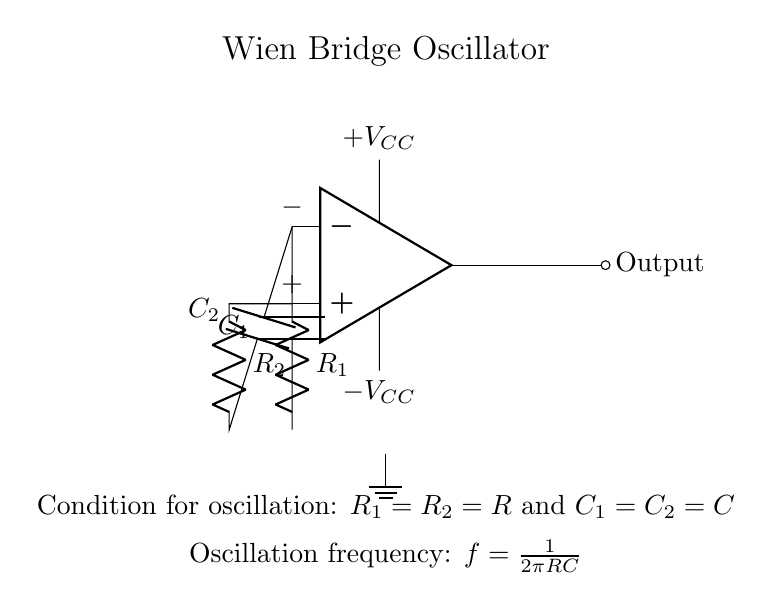What type of amplifier is used in the circuit? The circuit utilizes an operational amplifier (op-amp) as indicated by the symbol in the diagram.
Answer: operational amplifier What components are used to determine the oscillation frequency? The oscillation frequency depends on the resistors R and capacitors C, as described by the formula in the diagram.
Answer: R and C What is the condition for oscillation in this circuit? The condition for oscillation requires that both resistors R1 and R2 be equal, and that both capacitors C1 and C2 be equal, as specified in the circuit.
Answer: R1 = R2 and C1 = C2 What is the output connection type? The output is connected through a short to a node indicated as output (node on the right).
Answer: short What is the formula for oscillation frequency given in the circuit? The formula provided for oscillation frequency shows that it is inversely proportional to the product of resistance and capacitance.
Answer: f = 1/2πRC What is the supply voltage range for the op-amp? The circuit provides a dual power supply with a positive and a negative voltage, denoted as +VCC and -VCC respectively.
Answer: +VCC and -VCC How many capacitors are present in this circuit? The circuit contains two capacitors, labeled as C1 and C2.
Answer: two 